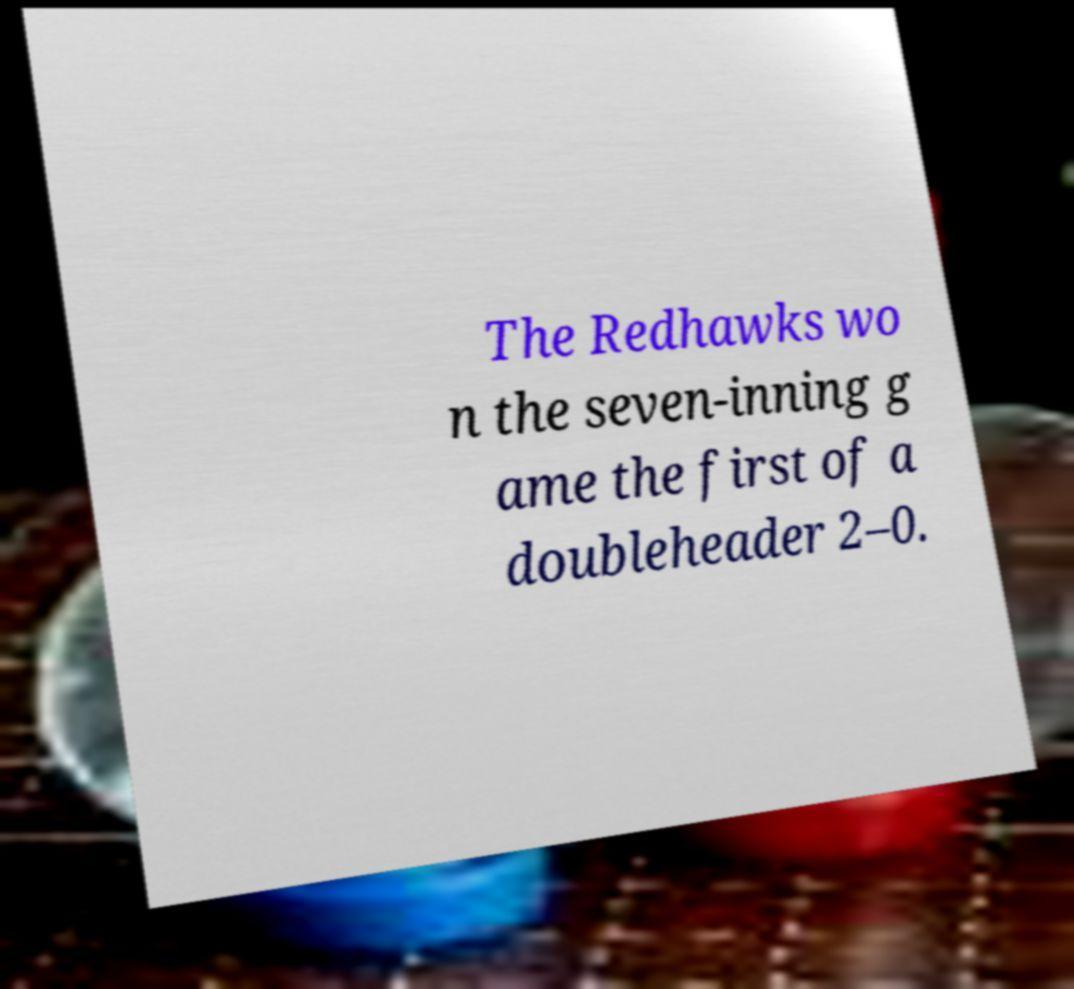Can you accurately transcribe the text from the provided image for me? The Redhawks wo n the seven-inning g ame the first of a doubleheader 2–0. 